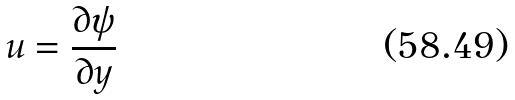<formula> <loc_0><loc_0><loc_500><loc_500>u = \frac { \partial \psi } { \partial y }</formula> 